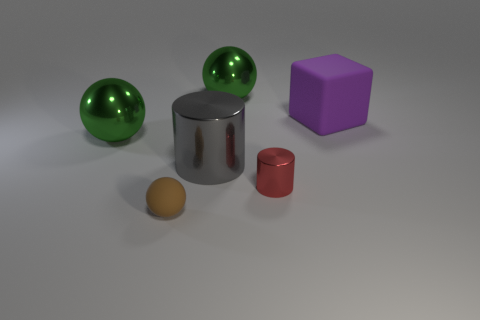Subtract all purple cylinders. How many green spheres are left? 2 Add 2 big matte blocks. How many objects exist? 8 Subtract all large spheres. How many spheres are left? 1 Subtract all cylinders. How many objects are left? 4 Subtract all blue spheres. Subtract all green cylinders. How many spheres are left? 3 Subtract all gray metal objects. Subtract all large shiny things. How many objects are left? 2 Add 3 large green shiny balls. How many large green shiny balls are left? 5 Add 5 red shiny cylinders. How many red shiny cylinders exist? 6 Subtract 0 yellow blocks. How many objects are left? 6 